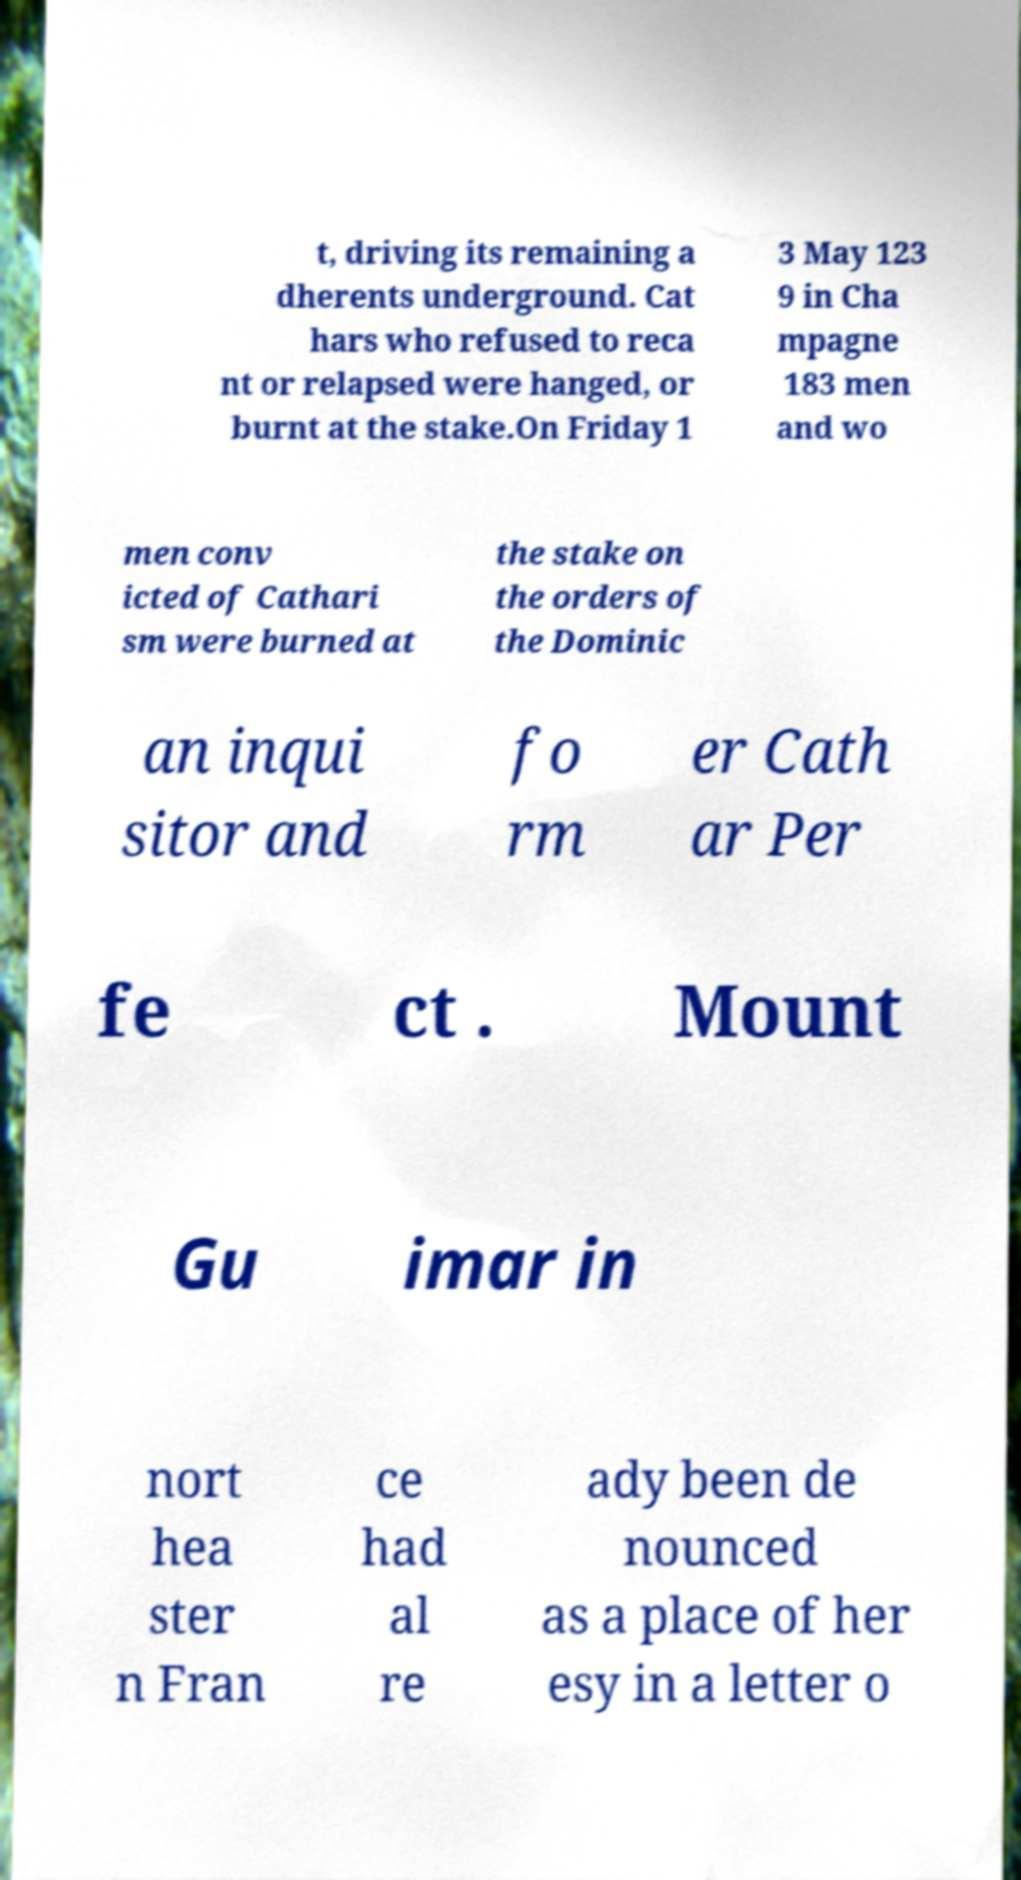There's text embedded in this image that I need extracted. Can you transcribe it verbatim? t, driving its remaining a dherents underground. Cat hars who refused to reca nt or relapsed were hanged, or burnt at the stake.On Friday 1 3 May 123 9 in Cha mpagne 183 men and wo men conv icted of Cathari sm were burned at the stake on the orders of the Dominic an inqui sitor and fo rm er Cath ar Per fe ct . Mount Gu imar in nort hea ster n Fran ce had al re ady been de nounced as a place of her esy in a letter o 